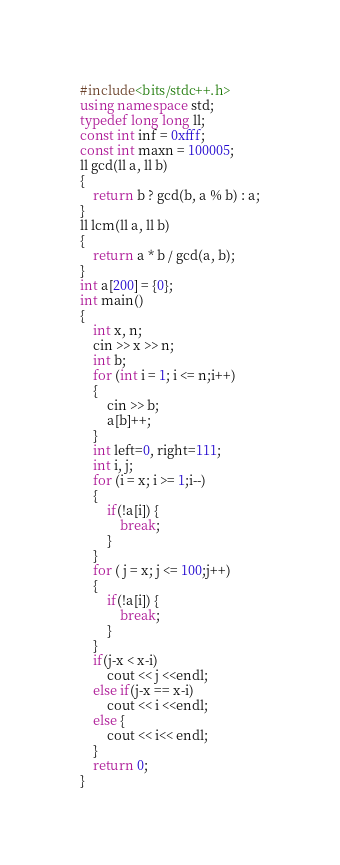Convert code to text. <code><loc_0><loc_0><loc_500><loc_500><_C++_>#include<bits/stdc++.h>
using namespace std;
typedef long long ll;
const int inf = 0xfff;
const int maxn = 100005;
ll gcd(ll a, ll b)
{
	return b ? gcd(b, a % b) : a;
}
ll lcm(ll a, ll b)
{
	return a * b / gcd(a, b);
}
int a[200] = {0};
int main()
{
    int x, n;
    cin >> x >> n;
    int b;
    for (int i = 1; i <= n;i++)
    {
        cin >> b;
        a[b]++;
    }
    int left=0, right=111;
    int i, j;
    for (i = x; i >= 1;i--)
    {
        if(!a[i]) {
            break;
        }
    }
    for ( j = x; j <= 100;j++)
    {
        if(!a[i]) {
            break;
        }
    }
    if(j-x < x-i)
        cout << j <<endl;
    else if(j-x == x-i)
        cout << i <<endl;
    else {
        cout << i<< endl;
    }
    return 0;
}</code> 